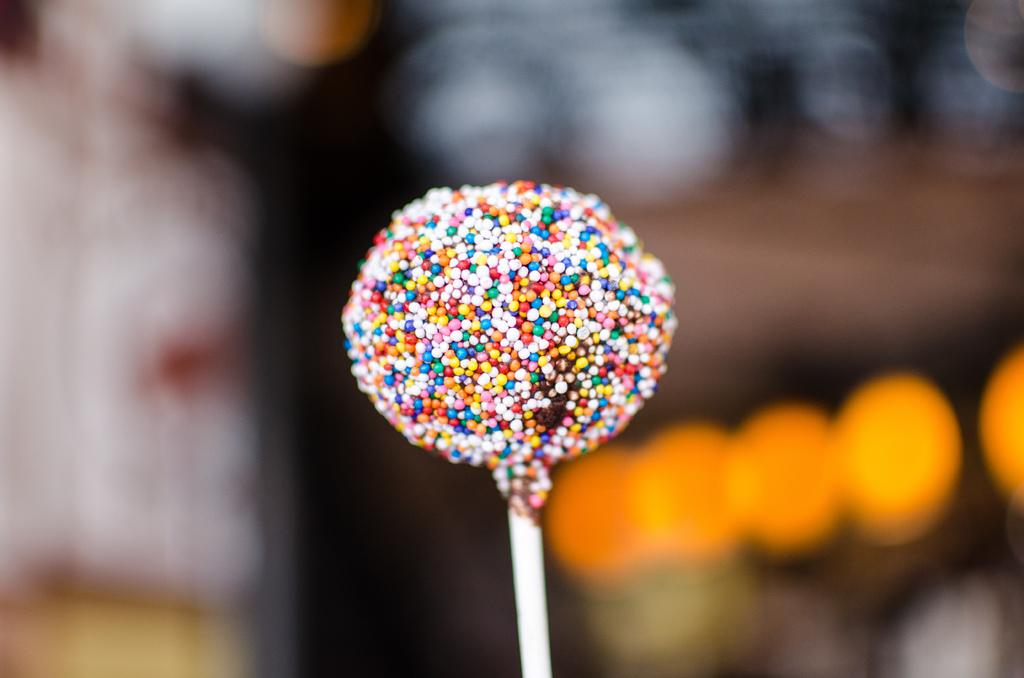What type of sweet can be seen in the image? There is a sweet candy in the image. Can you describe the background of the image? The background of the image is blurred. What type of drum is being played in the background of the image? There is no drum present in the image; the background is blurred. 